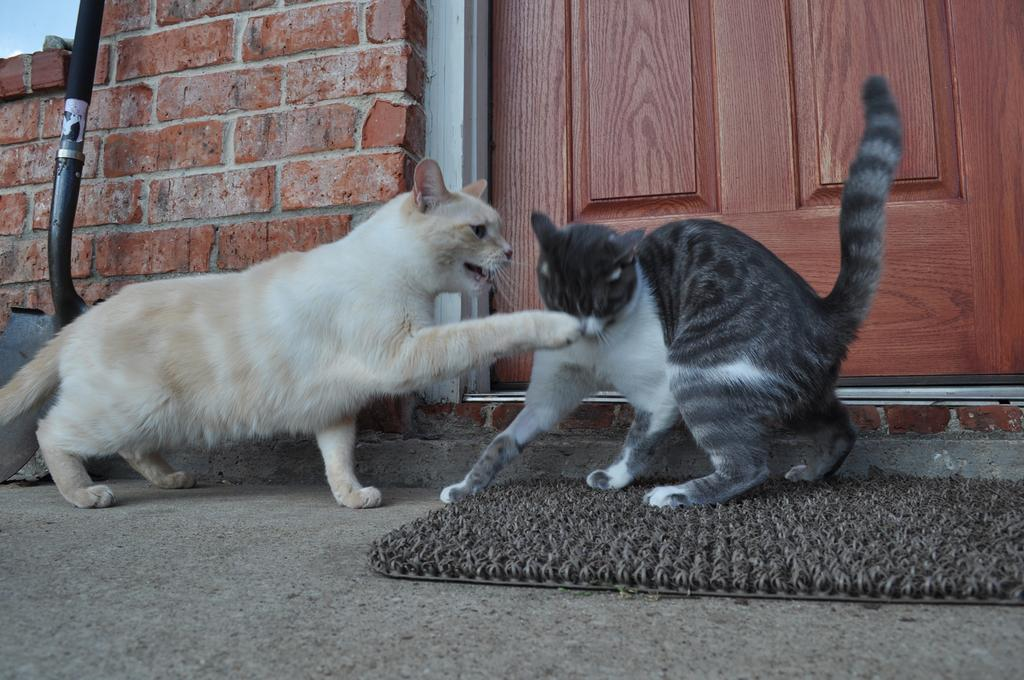How many cats are in the image? There are two cats in the image. What can be seen in the background of the image? There is a wall and a door in the background of the image. What type of attention is the cat in the image giving to the drawer? There is no drawer present in the image, so the cat cannot be giving attention to a drawer. 